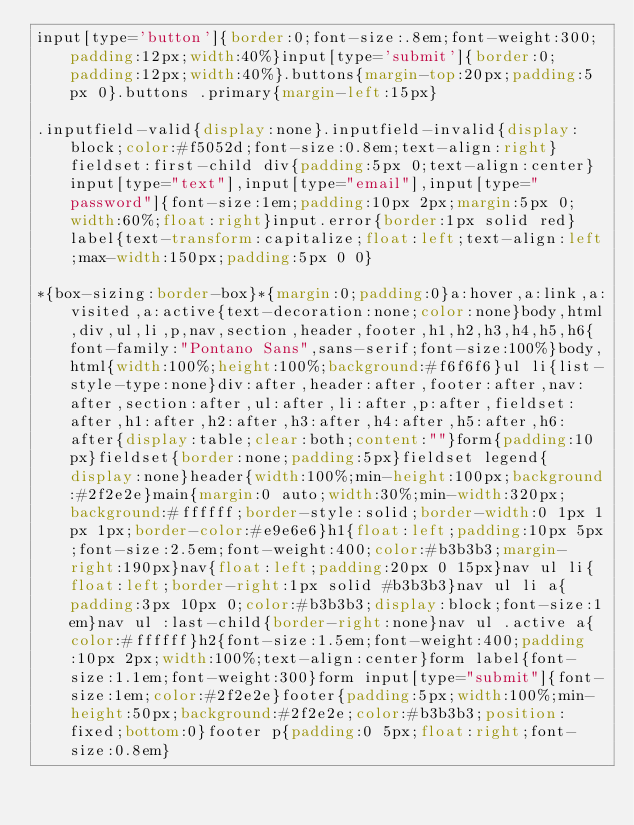<code> <loc_0><loc_0><loc_500><loc_500><_CSS_>input[type='button']{border:0;font-size:.8em;font-weight:300;padding:12px;width:40%}input[type='submit']{border:0;padding:12px;width:40%}.buttons{margin-top:20px;padding:5px 0}.buttons .primary{margin-left:15px}

.inputfield-valid{display:none}.inputfield-invalid{display:block;color:#f5052d;font-size:0.8em;text-align:right}fieldset:first-child div{padding:5px 0;text-align:center}input[type="text"],input[type="email"],input[type="password"]{font-size:1em;padding:10px 2px;margin:5px 0;width:60%;float:right}input.error{border:1px solid red}label{text-transform:capitalize;float:left;text-align:left;max-width:150px;padding:5px 0 0}

*{box-sizing:border-box}*{margin:0;padding:0}a:hover,a:link,a:visited,a:active{text-decoration:none;color:none}body,html,div,ul,li,p,nav,section,header,footer,h1,h2,h3,h4,h5,h6{font-family:"Pontano Sans",sans-serif;font-size:100%}body,html{width:100%;height:100%;background:#f6f6f6}ul li{list-style-type:none}div:after,header:after,footer:after,nav:after,section:after,ul:after,li:after,p:after,fieldset:after,h1:after,h2:after,h3:after,h4:after,h5:after,h6:after{display:table;clear:both;content:""}form{padding:10px}fieldset{border:none;padding:5px}fieldset legend{display:none}header{width:100%;min-height:100px;background:#2f2e2e}main{margin:0 auto;width:30%;min-width:320px;background:#ffffff;border-style:solid;border-width:0 1px 1px 1px;border-color:#e9e6e6}h1{float:left;padding:10px 5px;font-size:2.5em;font-weight:400;color:#b3b3b3;margin-right:190px}nav{float:left;padding:20px 0 15px}nav ul li{float:left;border-right:1px solid #b3b3b3}nav ul li a{padding:3px 10px 0;color:#b3b3b3;display:block;font-size:1em}nav ul :last-child{border-right:none}nav ul .active a{color:#ffffff}h2{font-size:1.5em;font-weight:400;padding:10px 2px;width:100%;text-align:center}form label{font-size:1.1em;font-weight:300}form input[type="submit"]{font-size:1em;color:#2f2e2e}footer{padding:5px;width:100%;min-height:50px;background:#2f2e2e;color:#b3b3b3;position:fixed;bottom:0}footer p{padding:0 5px;float:right;font-size:0.8em}
</code> 